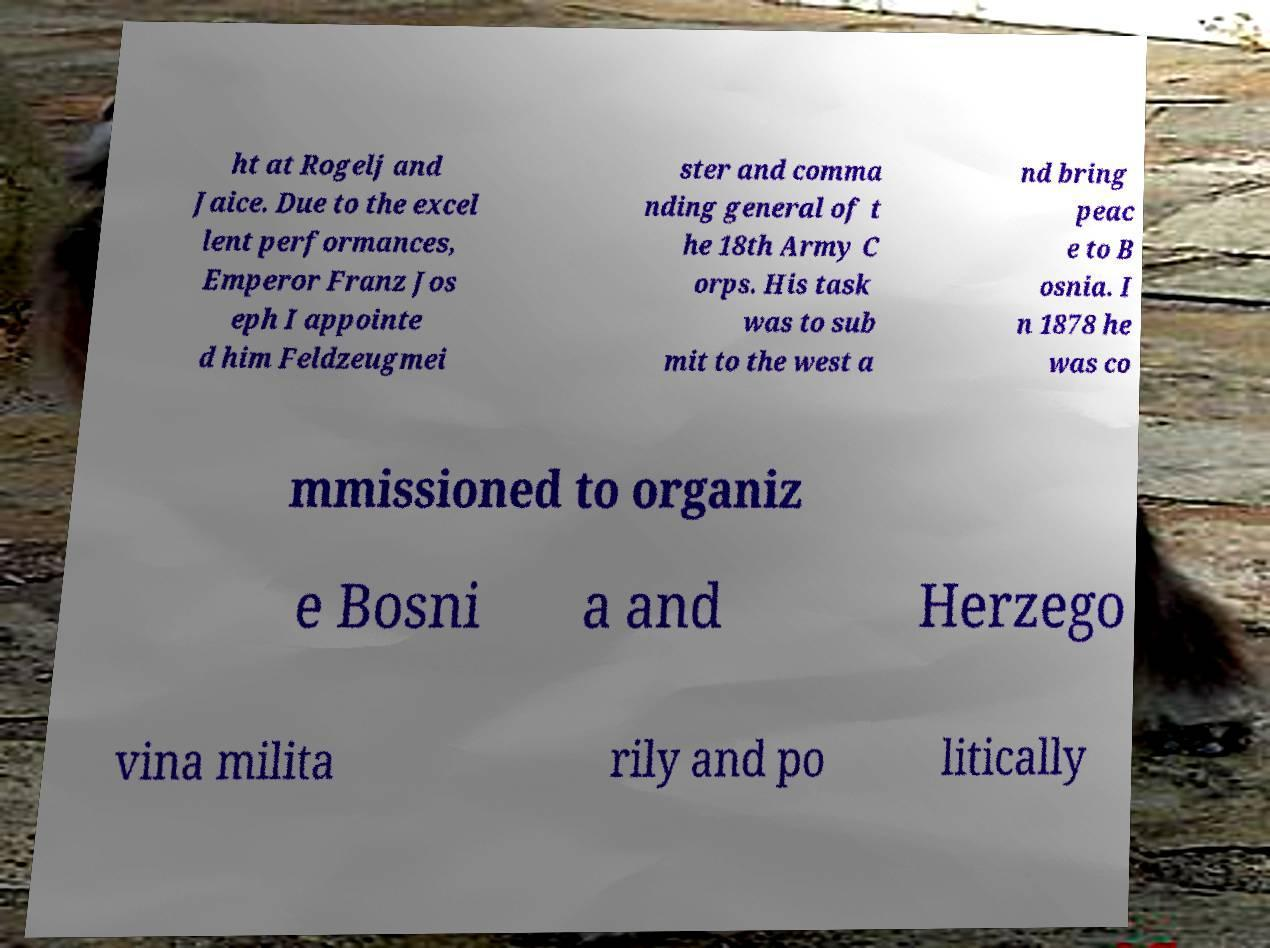Can you accurately transcribe the text from the provided image for me? ht at Rogelj and Jaice. Due to the excel lent performances, Emperor Franz Jos eph I appointe d him Feldzeugmei ster and comma nding general of t he 18th Army C orps. His task was to sub mit to the west a nd bring peac e to B osnia. I n 1878 he was co mmissioned to organiz e Bosni a and Herzego vina milita rily and po litically 